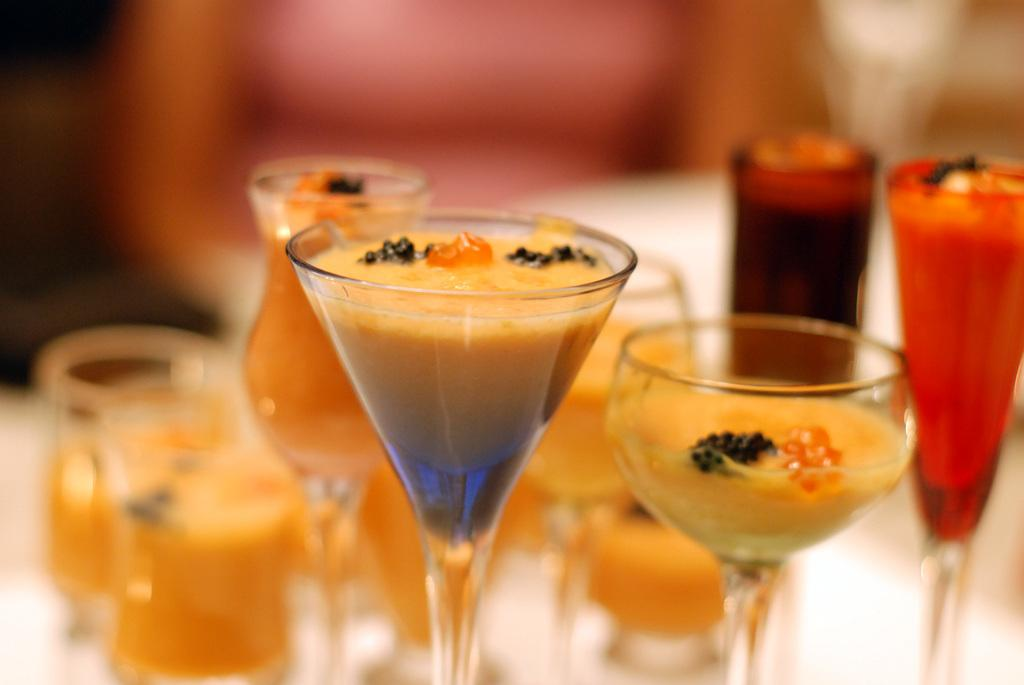What objects are in the image that are typically used for drinking? There are glasses in the image. What is inside the glasses in the image? The glasses contain some liquid. How many basketballs can be seen in the image? There are no basketballs present in the image. What type of yard game is being played in the image? There is no yard game being played in the image. 